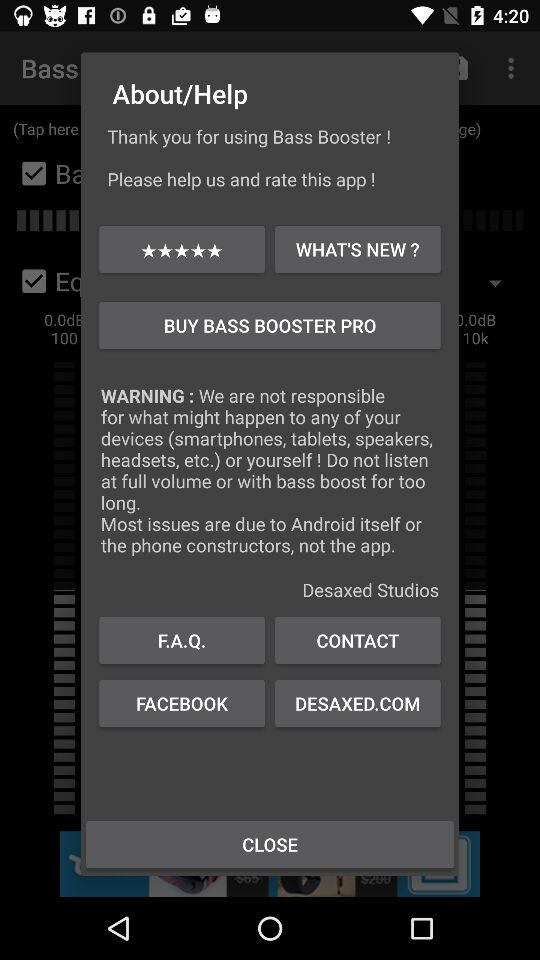What is the shown warning? The shown warning is "We are not responsible for what might happen to any of your devices (smartphones, tablets, speakers, headsets, etc.) or yourself! Do not listen at full volume or with bass boost for too long. Most issues are due to Android itself or the phone constructors, not the app". 